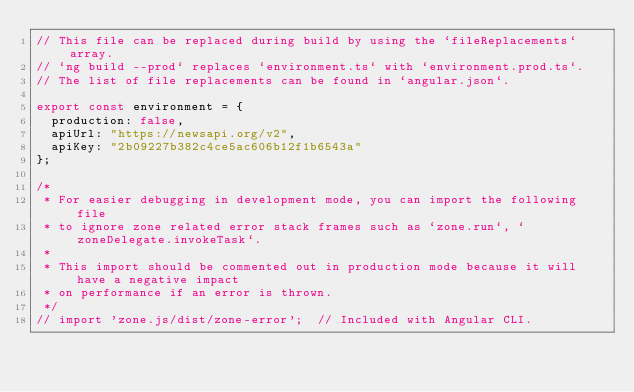Convert code to text. <code><loc_0><loc_0><loc_500><loc_500><_TypeScript_>// This file can be replaced during build by using the `fileReplacements` array.
// `ng build --prod` replaces `environment.ts` with `environment.prod.ts`.
// The list of file replacements can be found in `angular.json`.

export const environment = {
  production: false,
  apiUrl: "https://newsapi.org/v2",
  apiKey: "2b09227b382c4ce5ac606b12f1b6543a"
};

/*
 * For easier debugging in development mode, you can import the following file
 * to ignore zone related error stack frames such as `zone.run`, `zoneDelegate.invokeTask`.
 *
 * This import should be commented out in production mode because it will have a negative impact
 * on performance if an error is thrown.
 */
// import 'zone.js/dist/zone-error';  // Included with Angular CLI.
</code> 